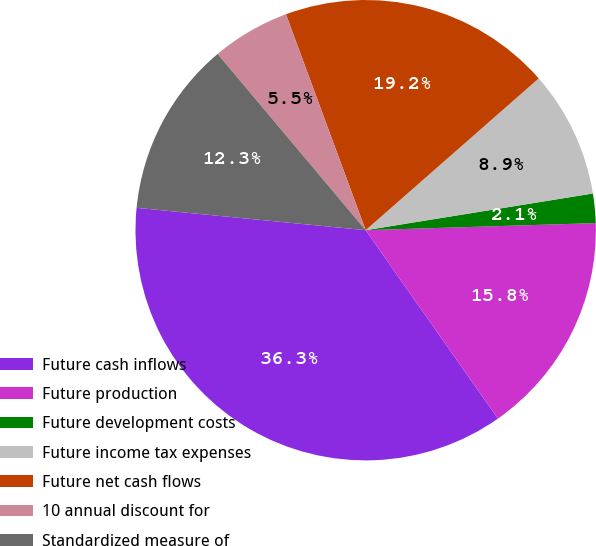Convert chart. <chart><loc_0><loc_0><loc_500><loc_500><pie_chart><fcel>Future cash inflows<fcel>Future production<fcel>Future development costs<fcel>Future income tax expenses<fcel>Future net cash flows<fcel>10 annual discount for<fcel>Standardized measure of<nl><fcel>36.29%<fcel>15.75%<fcel>2.06%<fcel>8.91%<fcel>19.17%<fcel>5.49%<fcel>12.33%<nl></chart> 